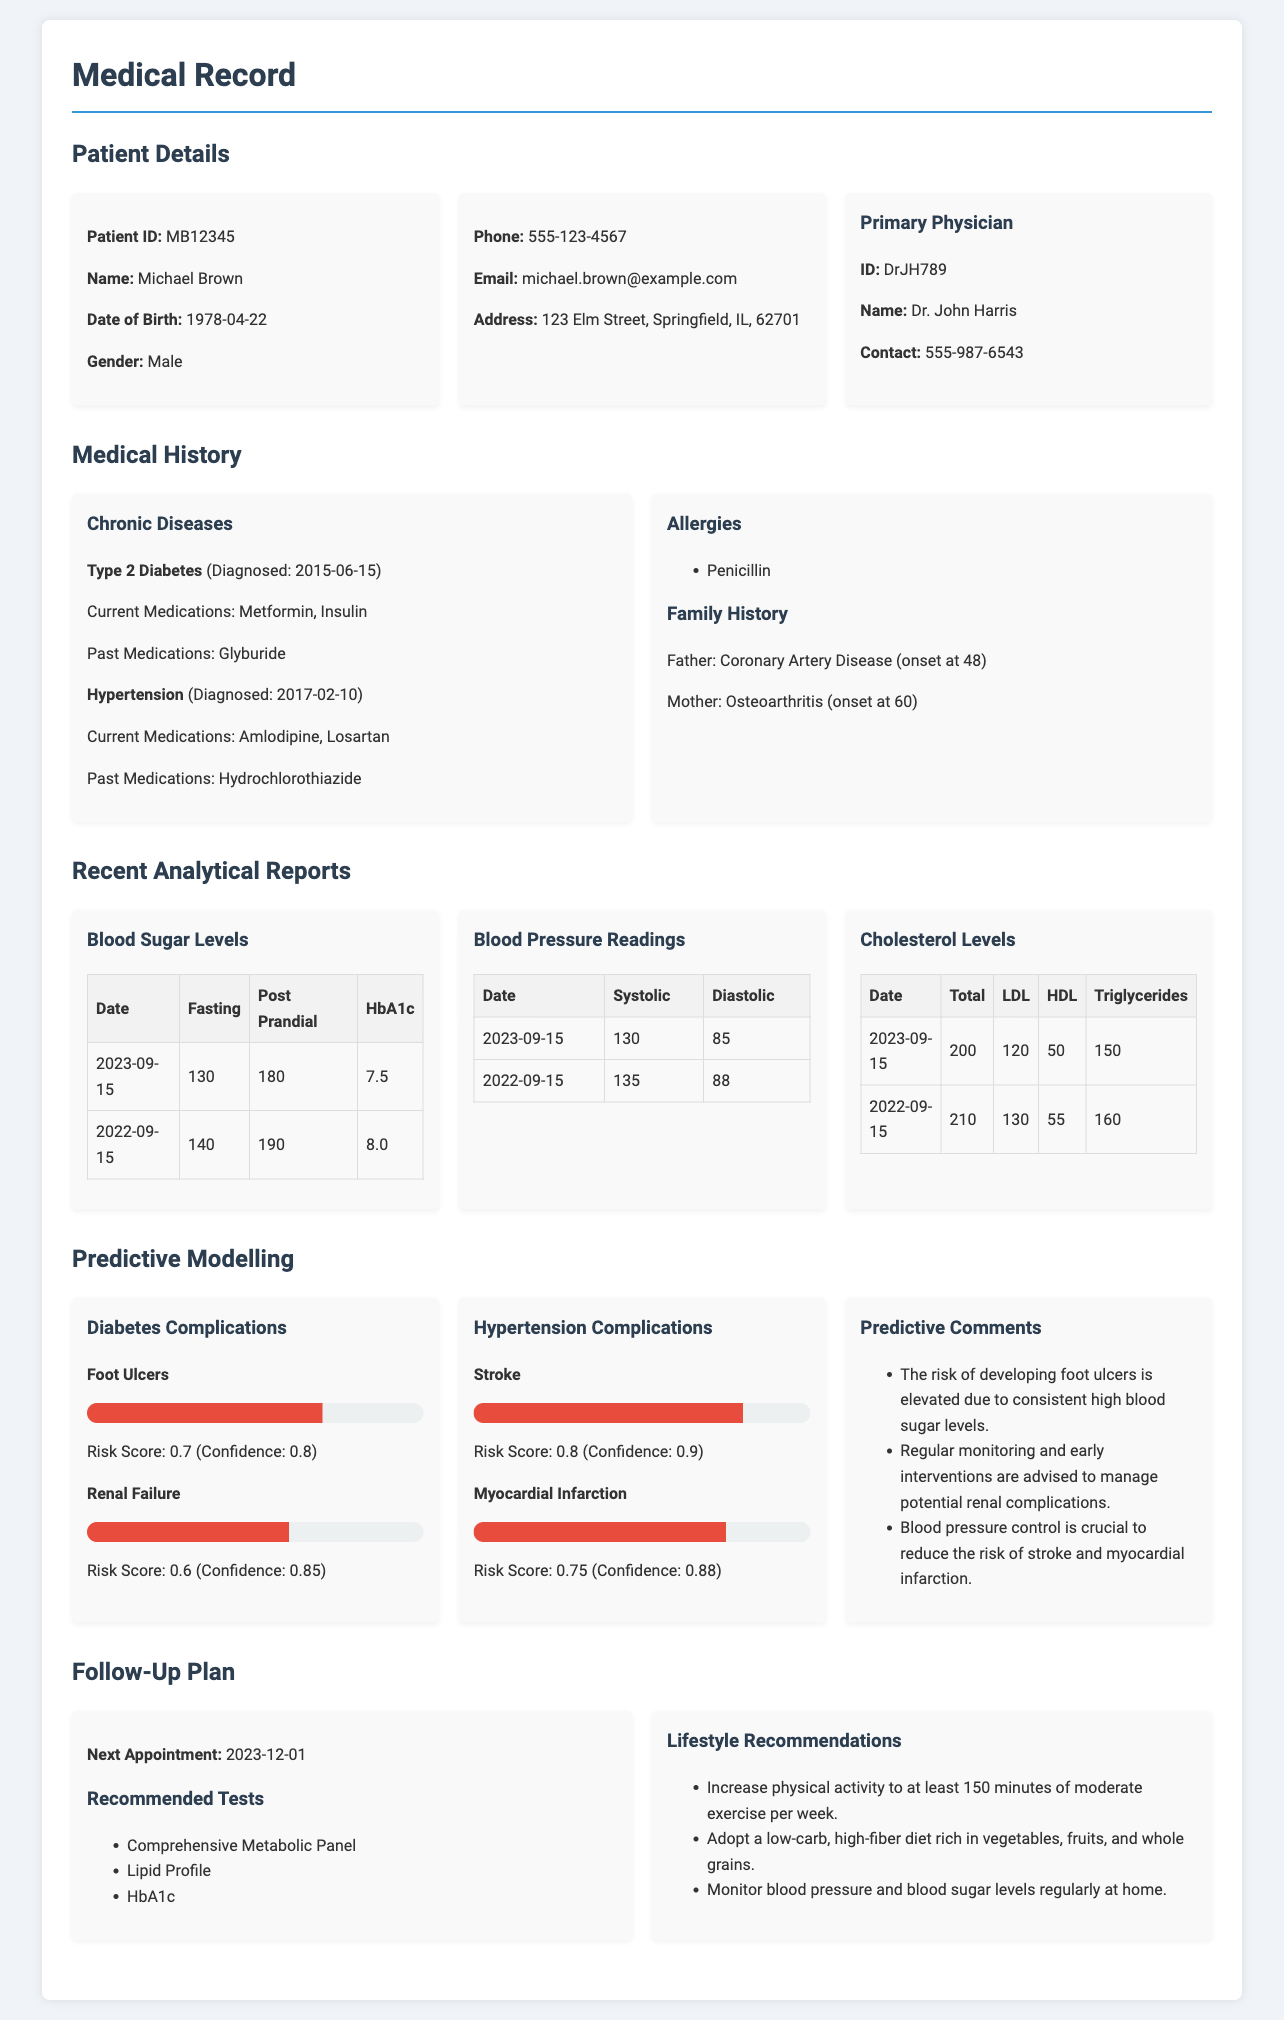what is the patient ID? The patient ID is listed under Patient Details in the document.
Answer: MB12345 who is the primary physician? The primary physician's name appears in the Patient Details section.
Answer: Dr. John Harris what medication is currently used for Hypertension? The current medications for Hypertension are mentioned in the Medical History section.
Answer: Amlodipine, Losartan when was the last blood sugar level test conducted? The most recent date for blood sugar levels can be found in the Recent Analytical Reports section.
Answer: 2023-09-15 what is the risk score for Stroke? The risk score for Stroke is listed under Predictive Modelling.
Answer: 0.8 what lifestyle recommendation is given? One of the lifestyle recommendations appears in the Follow-Up Plan section.
Answer: Increase physical activity to at least 150 minutes of moderate exercise per week how many years has the patient been diagnosed with Type 2 Diabetes as of the current date? The document notes the diagnosis date, allowing us to calculate from that date to the current year.
Answer: 8 years what is the confidence level for the Foot Ulcers risk score? The confidence level for the Foot Ulcers is mentioned under the Predictive Modelling section.
Answer: 0.8 